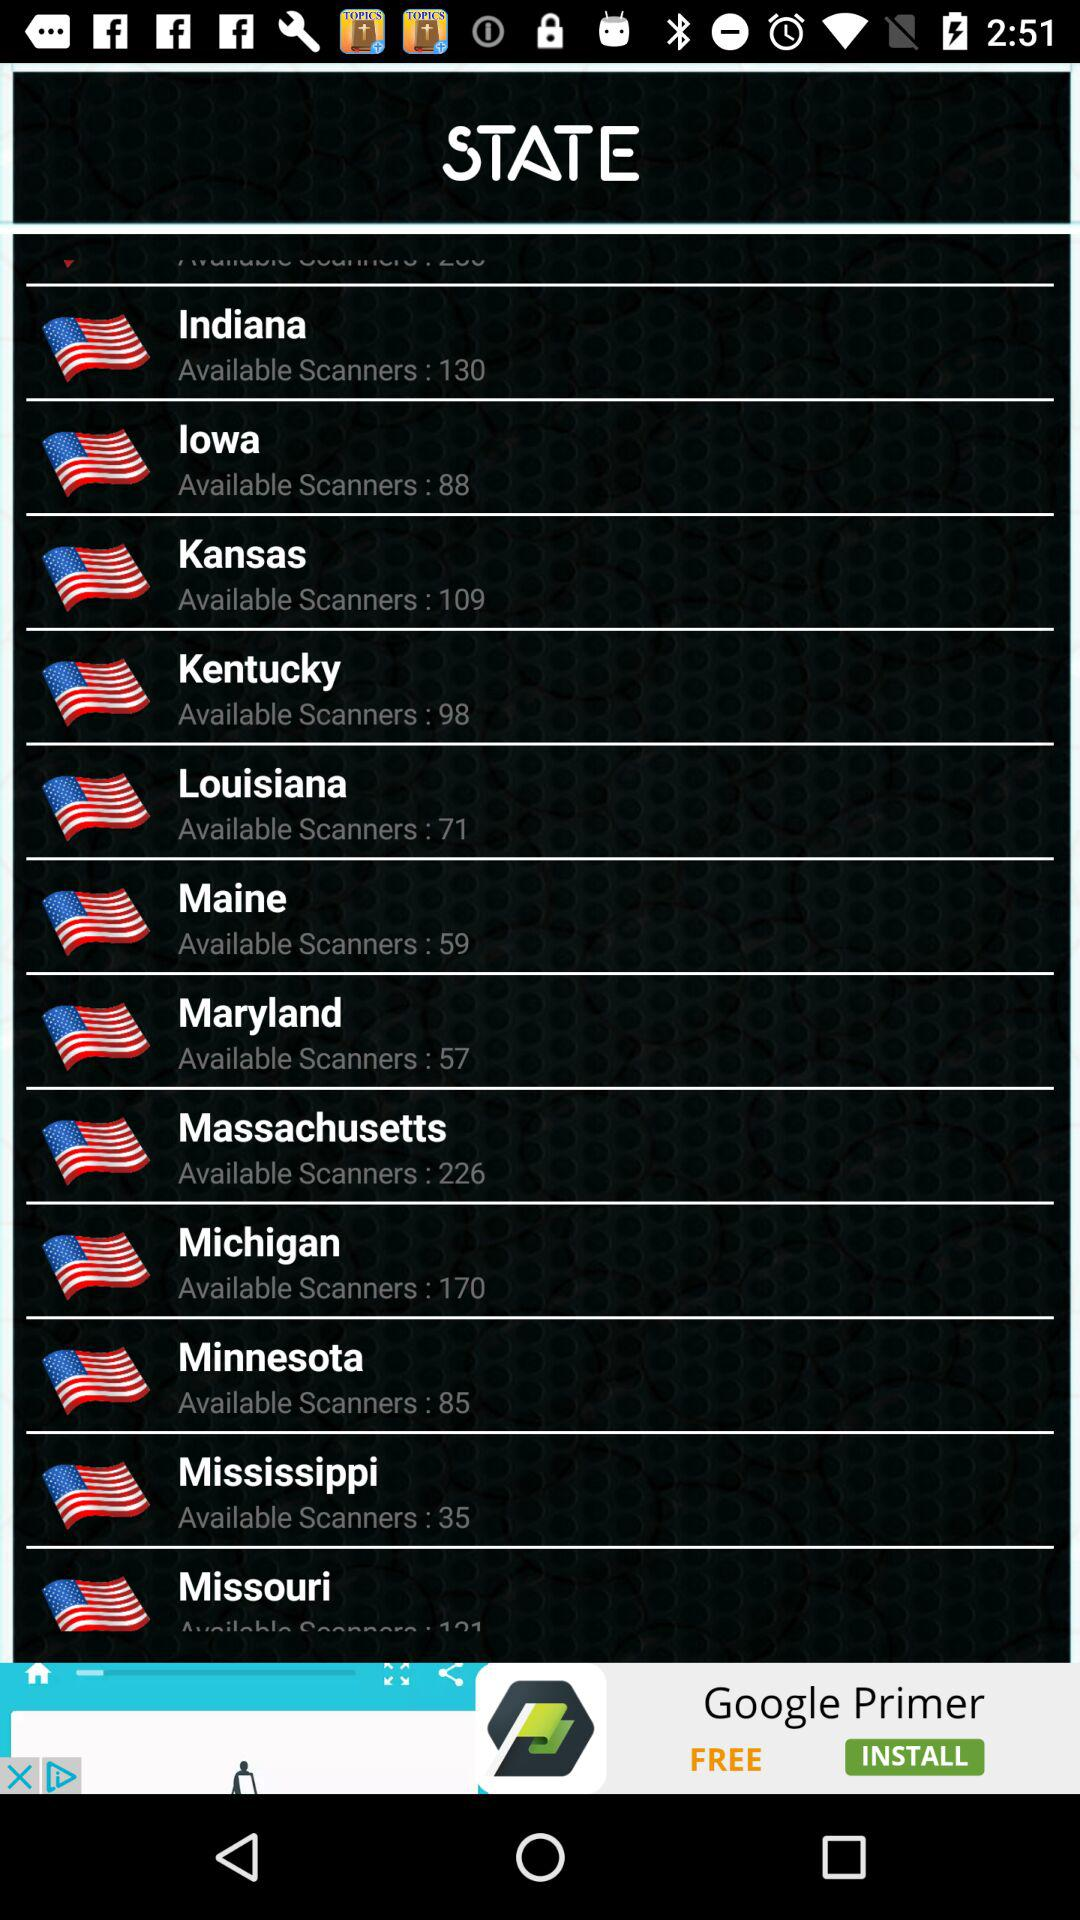How many scanners are there in Indiana? There are 130 scanners in Indiana. 